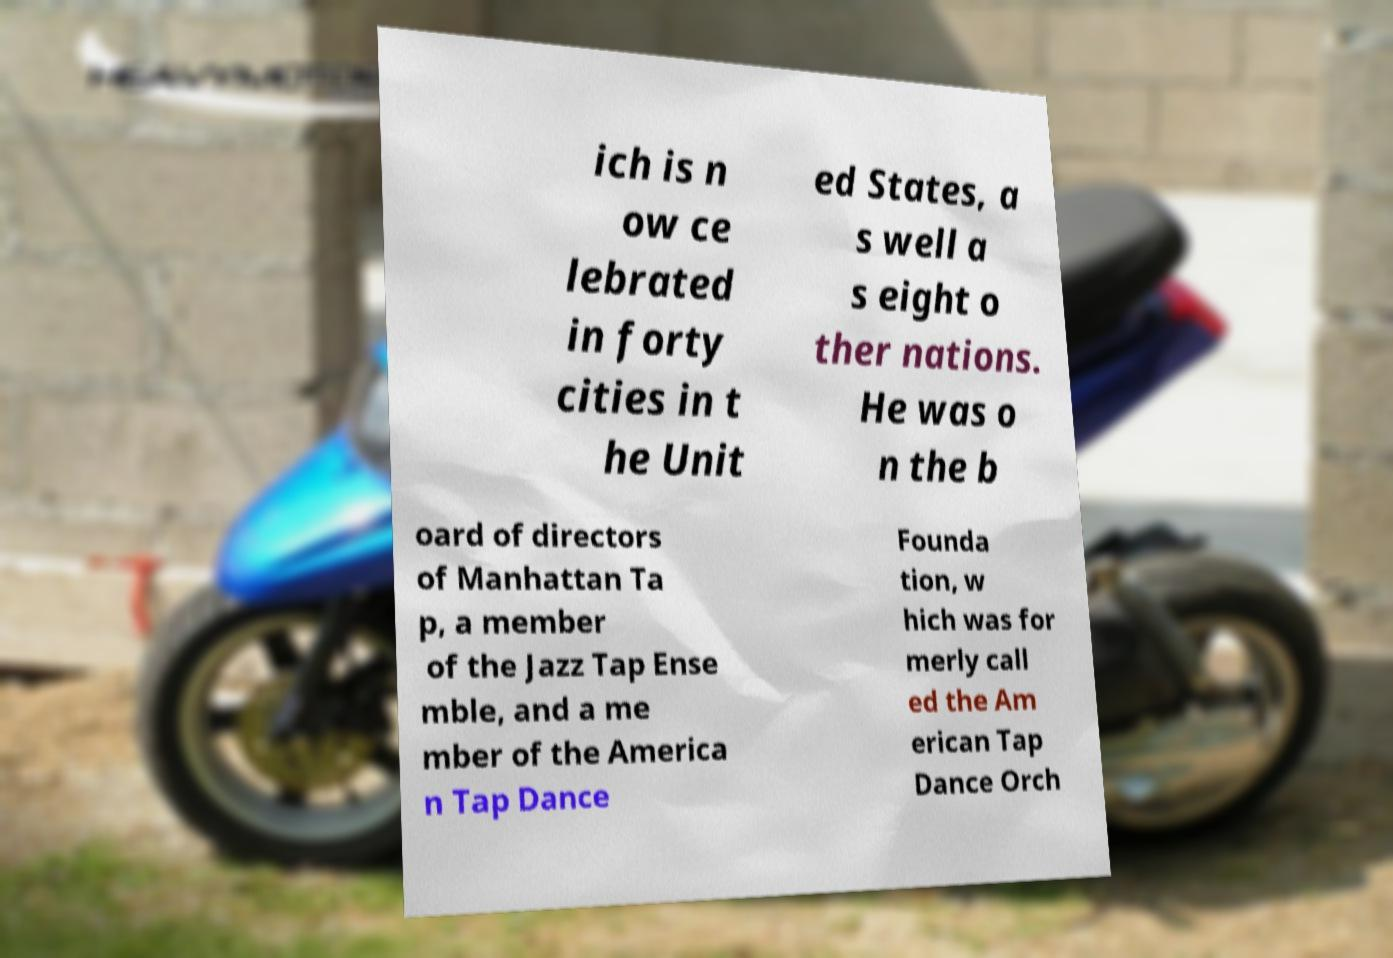For documentation purposes, I need the text within this image transcribed. Could you provide that? ich is n ow ce lebrated in forty cities in t he Unit ed States, a s well a s eight o ther nations. He was o n the b oard of directors of Manhattan Ta p, a member of the Jazz Tap Ense mble, and a me mber of the America n Tap Dance Founda tion, w hich was for merly call ed the Am erican Tap Dance Orch 